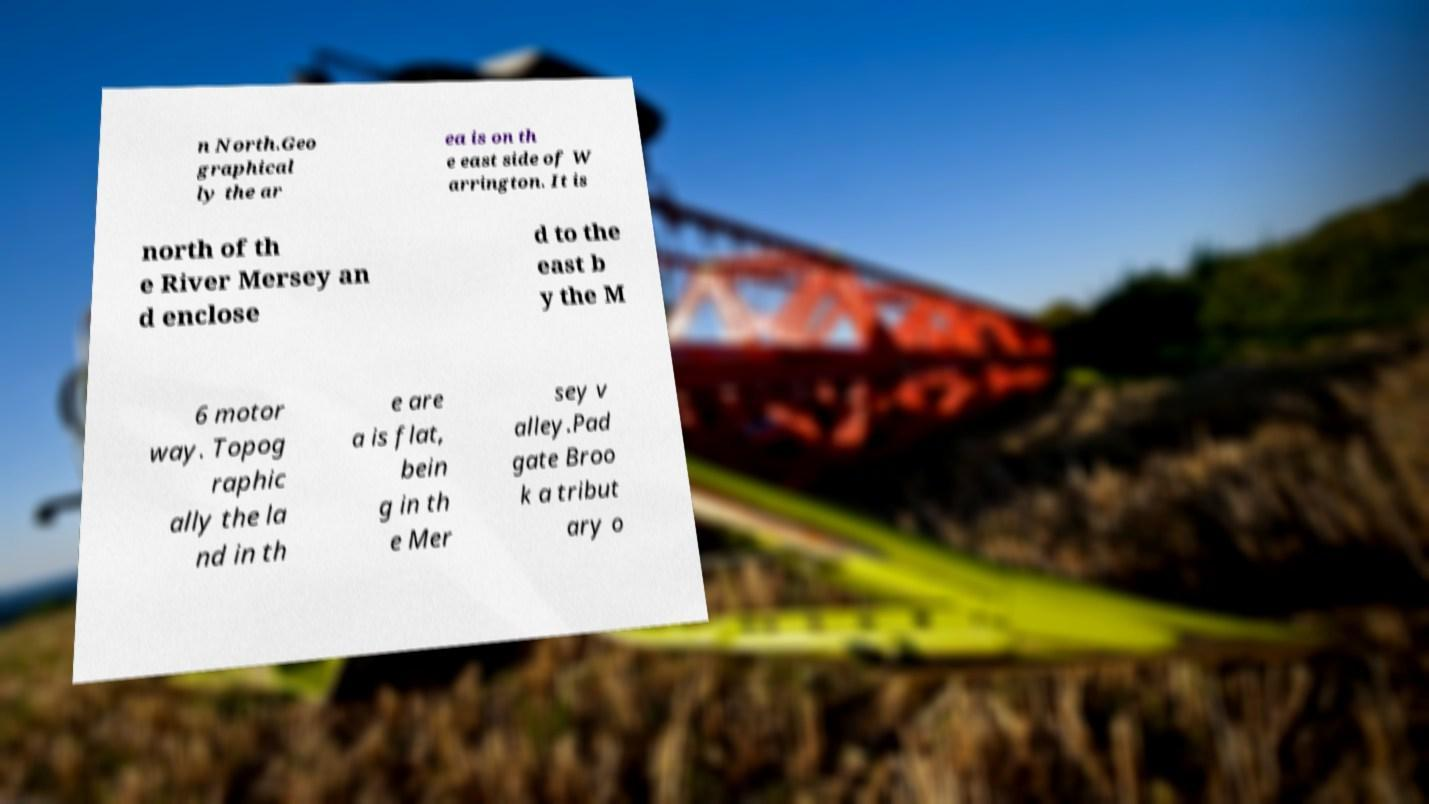Could you assist in decoding the text presented in this image and type it out clearly? n North.Geo graphical ly the ar ea is on th e east side of W arrington. It is north of th e River Mersey an d enclose d to the east b y the M 6 motor way. Topog raphic ally the la nd in th e are a is flat, bein g in th e Mer sey v alley.Pad gate Broo k a tribut ary o 